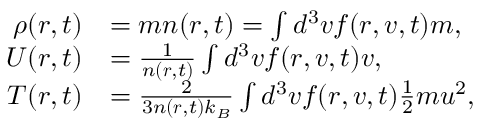<formula> <loc_0><loc_0><loc_500><loc_500>\begin{array} { r l } { \rho ( r , t ) } & { = m n ( r , t ) = \int d ^ { 3 } v f ( r , v , t ) m , } \\ { U ( r , t ) } & { = \frac { 1 } { n ( r , t ) } \int d ^ { 3 } v f ( r , v , t ) v , } \\ { T ( r , t ) } & { = \frac { 2 } { 3 n ( r , t ) k _ { B } } \int d ^ { 3 } v f ( r , v , t ) \frac { 1 } { 2 } m u ^ { 2 } , } \end{array}</formula> 